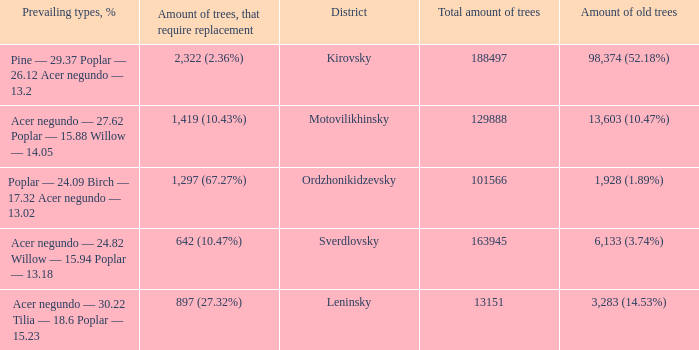What is the amount of trees, that require replacement when district is leninsky? 897 (27.32%). 